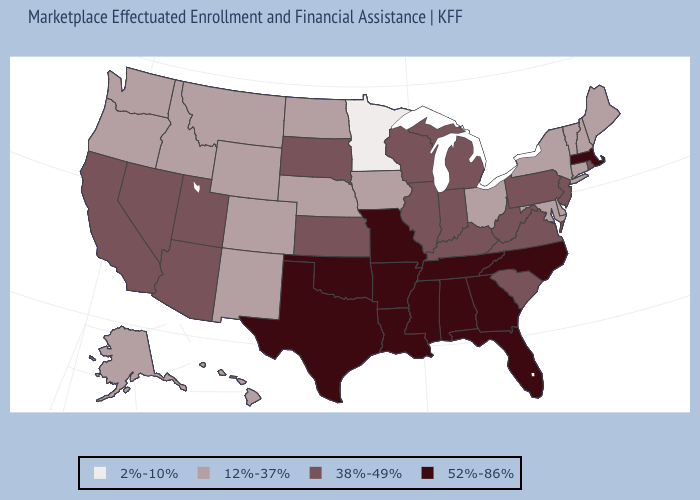Among the states that border Connecticut , does Massachusetts have the highest value?
Be succinct. Yes. Does Ohio have a lower value than Washington?
Quick response, please. No. How many symbols are there in the legend?
Short answer required. 4. Does Mississippi have the highest value in the USA?
Concise answer only. Yes. Does the map have missing data?
Be succinct. No. What is the value of California?
Give a very brief answer. 38%-49%. Which states hav the highest value in the South?
Answer briefly. Alabama, Arkansas, Florida, Georgia, Louisiana, Mississippi, North Carolina, Oklahoma, Tennessee, Texas. What is the value of Montana?
Concise answer only. 12%-37%. What is the value of Michigan?
Short answer required. 38%-49%. What is the value of Tennessee?
Concise answer only. 52%-86%. What is the value of Connecticut?
Quick response, please. 12%-37%. What is the highest value in states that border North Dakota?
Short answer required. 38%-49%. Name the states that have a value in the range 2%-10%?
Short answer required. Minnesota. How many symbols are there in the legend?
Keep it brief. 4. Does the map have missing data?
Write a very short answer. No. 